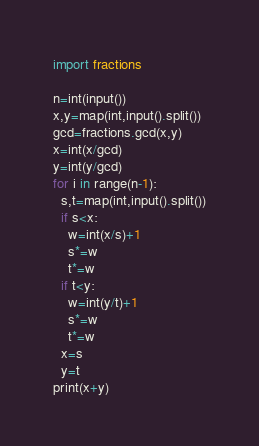<code> <loc_0><loc_0><loc_500><loc_500><_Python_>import fractions

n=int(input())
x,y=map(int,input().split())
gcd=fractions.gcd(x,y)
x=int(x/gcd)
y=int(y/gcd)
for i in range(n-1):
  s,t=map(int,input().split())
  if s<x:
    w=int(x/s)+1
    s*=w
    t*=w
  if t<y:
    w=int(y/t)+1
    s*=w
    t*=w
  x=s
  y=t
print(x+y)</code> 